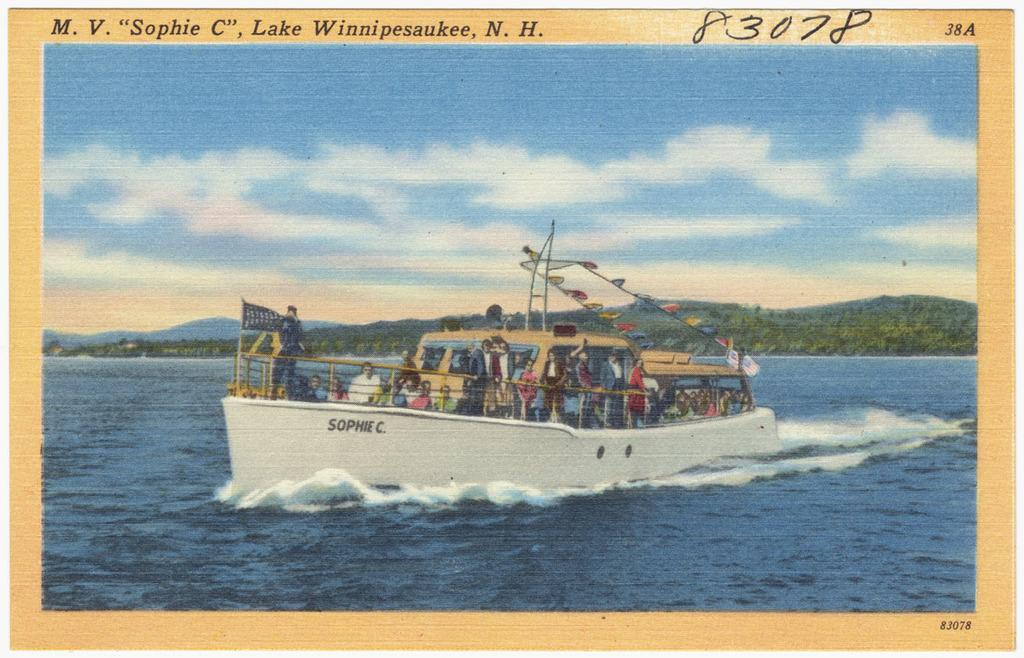<image>
Provide a brief description of the given image. A colorful postcard that is captioned M.V Sophie C, Lake Winnipesaukee, N.H. 